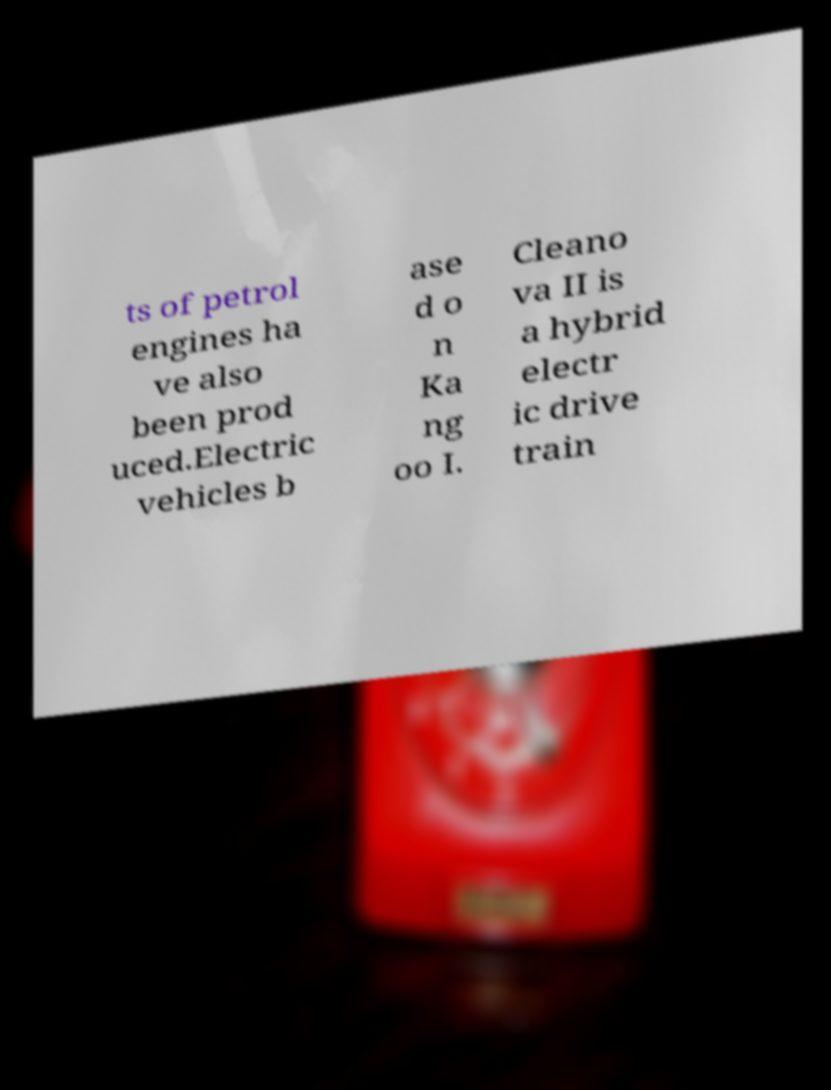Could you assist in decoding the text presented in this image and type it out clearly? ts of petrol engines ha ve also been prod uced.Electric vehicles b ase d o n Ka ng oo I. Cleano va II is a hybrid electr ic drive train 